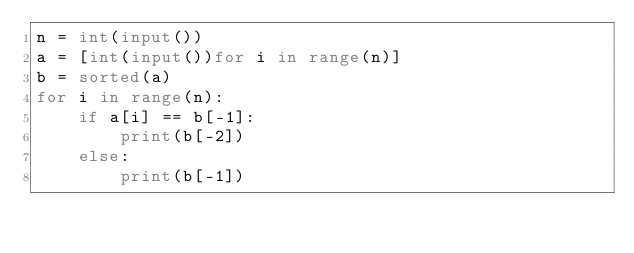<code> <loc_0><loc_0><loc_500><loc_500><_Python_>n = int(input())
a = [int(input())for i in range(n)]
b = sorted(a)
for i in range(n):
    if a[i] == b[-1]:
        print(b[-2])
    else:
        print(b[-1])</code> 